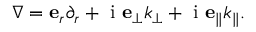<formula> <loc_0><loc_0><loc_500><loc_500>\begin{array} { r } { \nabla = e _ { r } \partial _ { r } + i e _ { \perp } k _ { \perp } + i e _ { \| } k _ { \| } . } \end{array}</formula> 